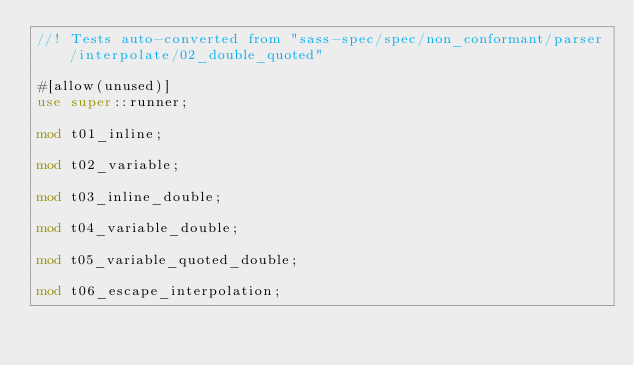<code> <loc_0><loc_0><loc_500><loc_500><_Rust_>//! Tests auto-converted from "sass-spec/spec/non_conformant/parser/interpolate/02_double_quoted"

#[allow(unused)]
use super::runner;

mod t01_inline;

mod t02_variable;

mod t03_inline_double;

mod t04_variable_double;

mod t05_variable_quoted_double;

mod t06_escape_interpolation;
</code> 